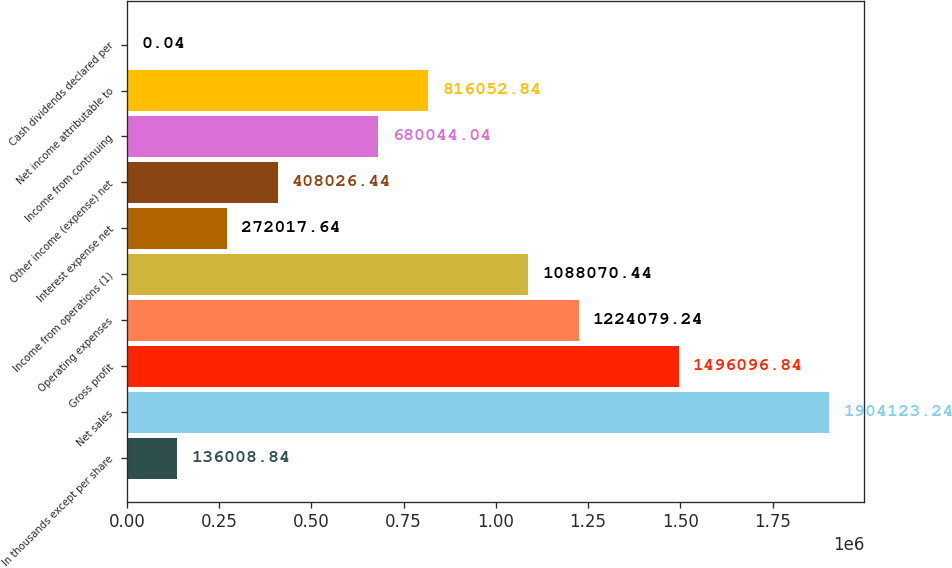<chart> <loc_0><loc_0><loc_500><loc_500><bar_chart><fcel>In thousands except per share<fcel>Net sales<fcel>Gross profit<fcel>Operating expenses<fcel>Income from operations (1)<fcel>Interest expense net<fcel>Other income (expense) net<fcel>Income from continuing<fcel>Net income attributable to<fcel>Cash dividends declared per<nl><fcel>136009<fcel>1.90412e+06<fcel>1.4961e+06<fcel>1.22408e+06<fcel>1.08807e+06<fcel>272018<fcel>408026<fcel>680044<fcel>816053<fcel>0.04<nl></chart> 